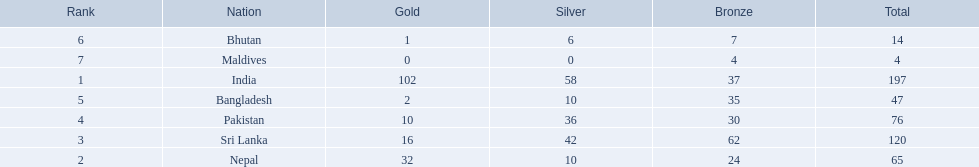Which countries won medals? India, Nepal, Sri Lanka, Pakistan, Bangladesh, Bhutan, Maldives. Which won the most? India. Which won the fewest? Maldives. 